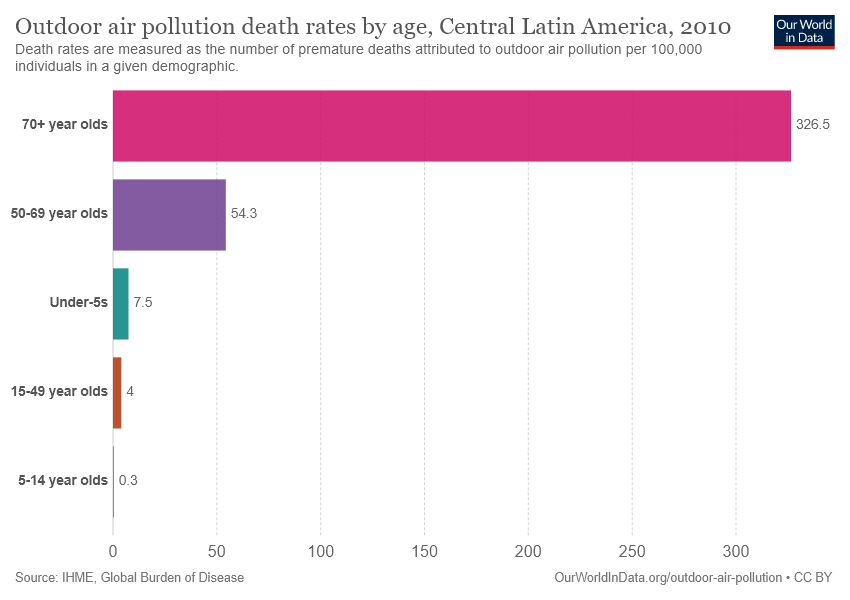Outline some significant characteristics in this image. The bar graph shows that the value 54.3 represents the age group of 50-69 year olds. The age group of 70 and older has a value greater than 50-69 years of age. 